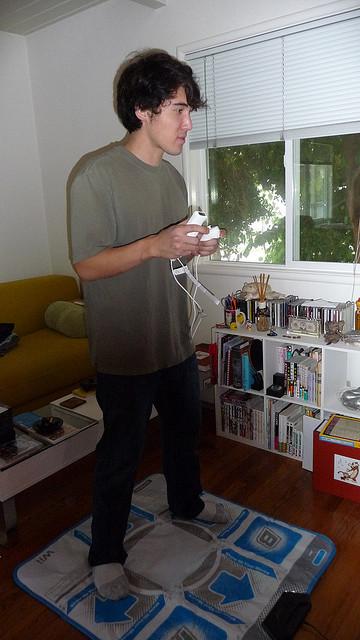Are the blinds all the way up?
Short answer required. No. Does he have shoes on?
Give a very brief answer. No. What is this man doing?
Concise answer only. Playing wii. What is the guy playing?
Give a very brief answer. Wii. What kind of blinds are on the window?
Concise answer only. White. What type of device is this man displaying in his left hand?
Quick response, please. Game controller. Is this man old enough to drink alcohol?
Give a very brief answer. No. 